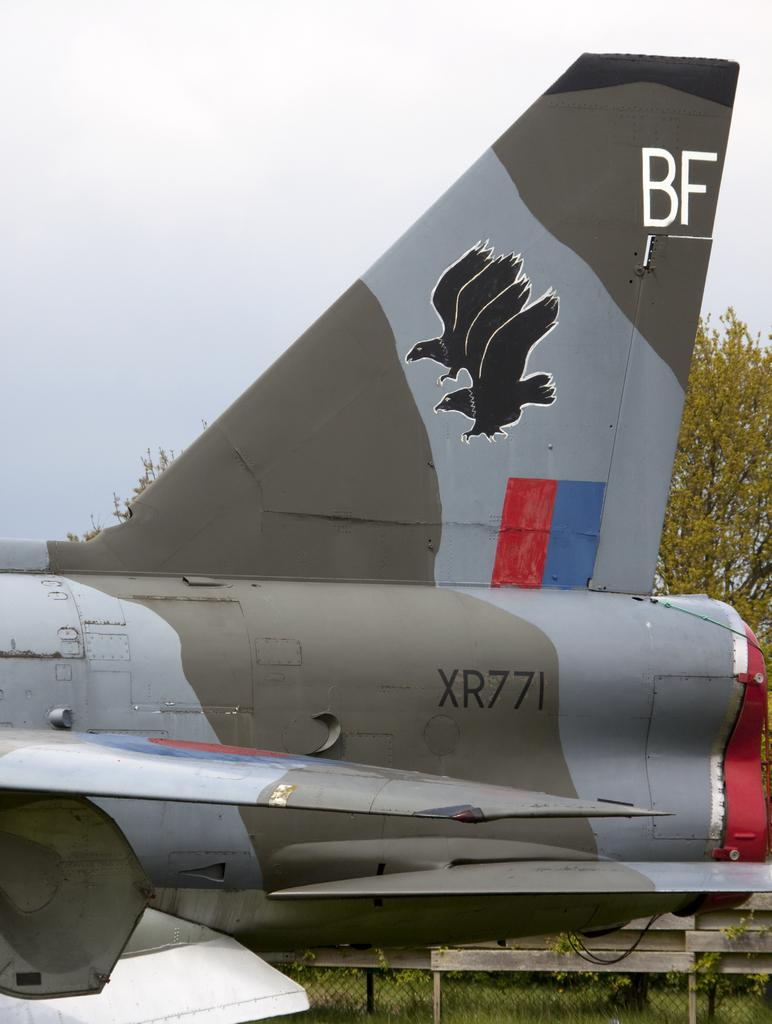<image>
Share a concise interpretation of the image provided. The rear section of an aircraft contains the label XR771. 